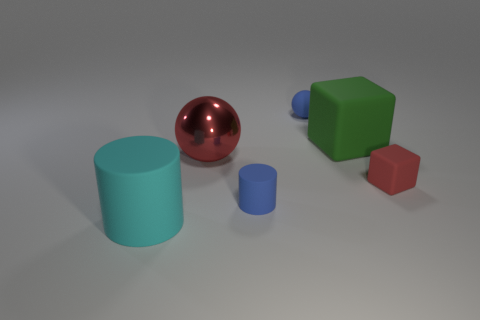The shiny thing that is the same color as the tiny matte block is what shape?
Make the answer very short. Sphere. Is there anything else that has the same material as the large green thing?
Your answer should be very brief. Yes. Is the shape of the blue matte thing in front of the big red shiny object the same as  the big red shiny thing?
Ensure brevity in your answer.  No. What is the material of the tiny cube?
Your answer should be compact. Rubber. What shape is the large matte thing on the left side of the small blue matte thing that is behind the tiny block that is behind the large cyan rubber thing?
Offer a terse response. Cylinder. How many other things are there of the same shape as the red matte object?
Give a very brief answer. 1. Is the color of the large shiny object the same as the small matte thing right of the blue sphere?
Keep it short and to the point. Yes. What number of large yellow metallic cubes are there?
Your answer should be compact. 0. How many things are either metallic spheres or blue matte objects?
Make the answer very short. 3. There is a metallic sphere that is the same color as the tiny cube; what size is it?
Your answer should be very brief. Large. 